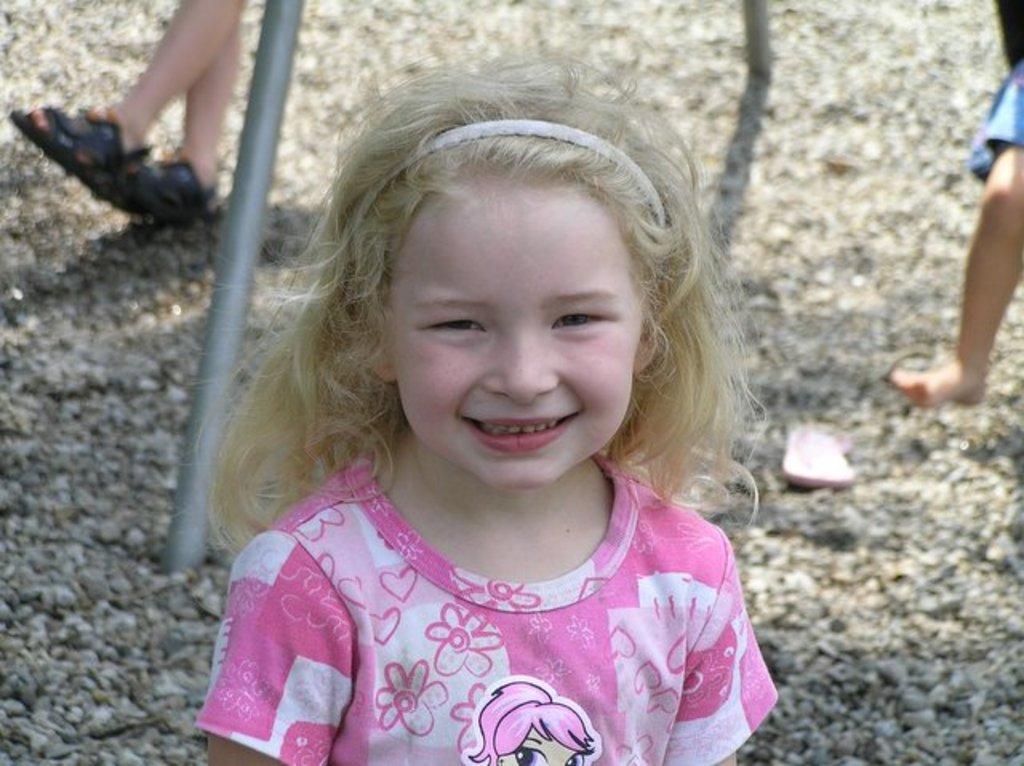Could you give a brief overview of what you see in this image? In this image there is a girl smiling, and in the background there are stones, two persons, iron rod and a slipper. 